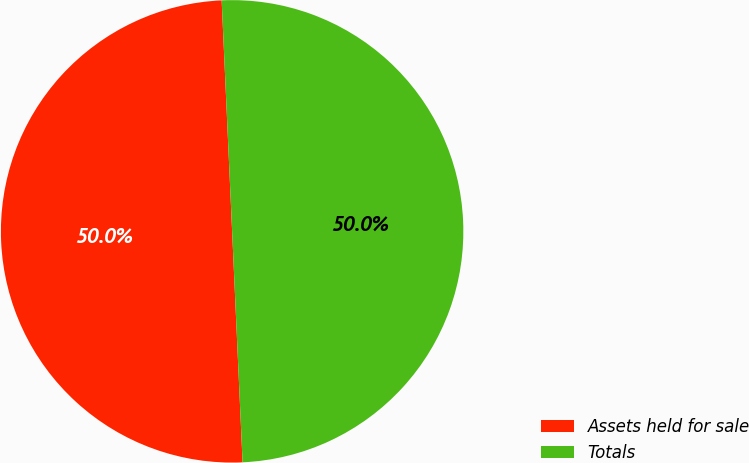Convert chart. <chart><loc_0><loc_0><loc_500><loc_500><pie_chart><fcel>Assets held for sale<fcel>Totals<nl><fcel>50.0%<fcel>50.0%<nl></chart> 